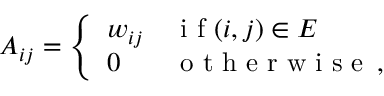<formula> <loc_0><loc_0><loc_500><loc_500>A _ { i j } = \left \{ \begin{array} { l l } { w _ { i j } } & { i f ( i , j ) \in E } \\ { 0 } & { o t h e r w i s e \, , } \end{array}</formula> 